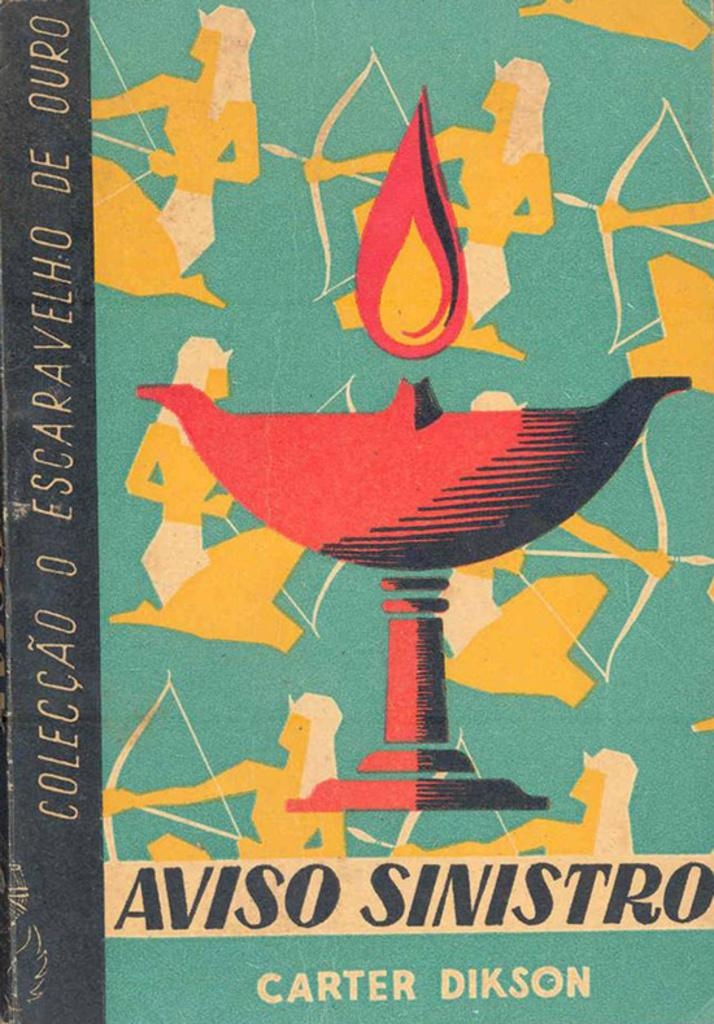<image>
Write a terse but informative summary of the picture. A book called Aviso Sinistro has a bright red cup on the cover. 